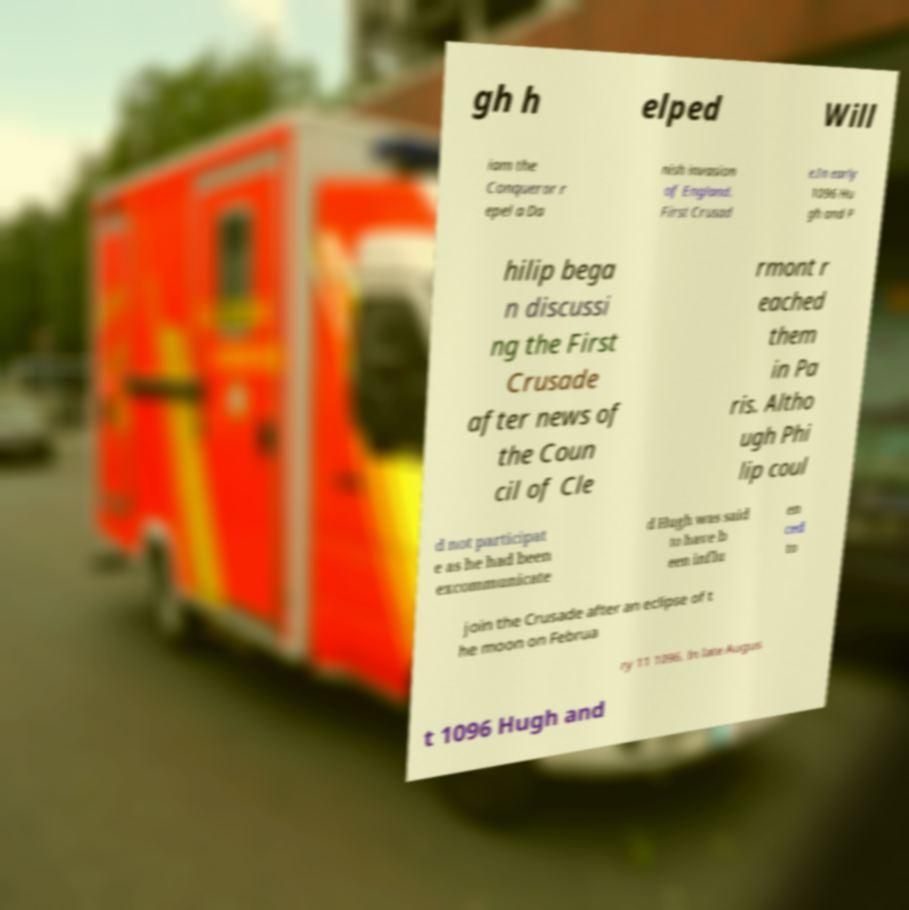I need the written content from this picture converted into text. Can you do that? gh h elped Will iam the Conqueror r epel a Da nish invasion of England. First Crusad e.In early 1096 Hu gh and P hilip bega n discussi ng the First Crusade after news of the Coun cil of Cle rmont r eached them in Pa ris. Altho ugh Phi lip coul d not participat e as he had been excommunicate d Hugh was said to have b een influ en ced to join the Crusade after an eclipse of t he moon on Februa ry 11 1096. In late Augus t 1096 Hugh and 